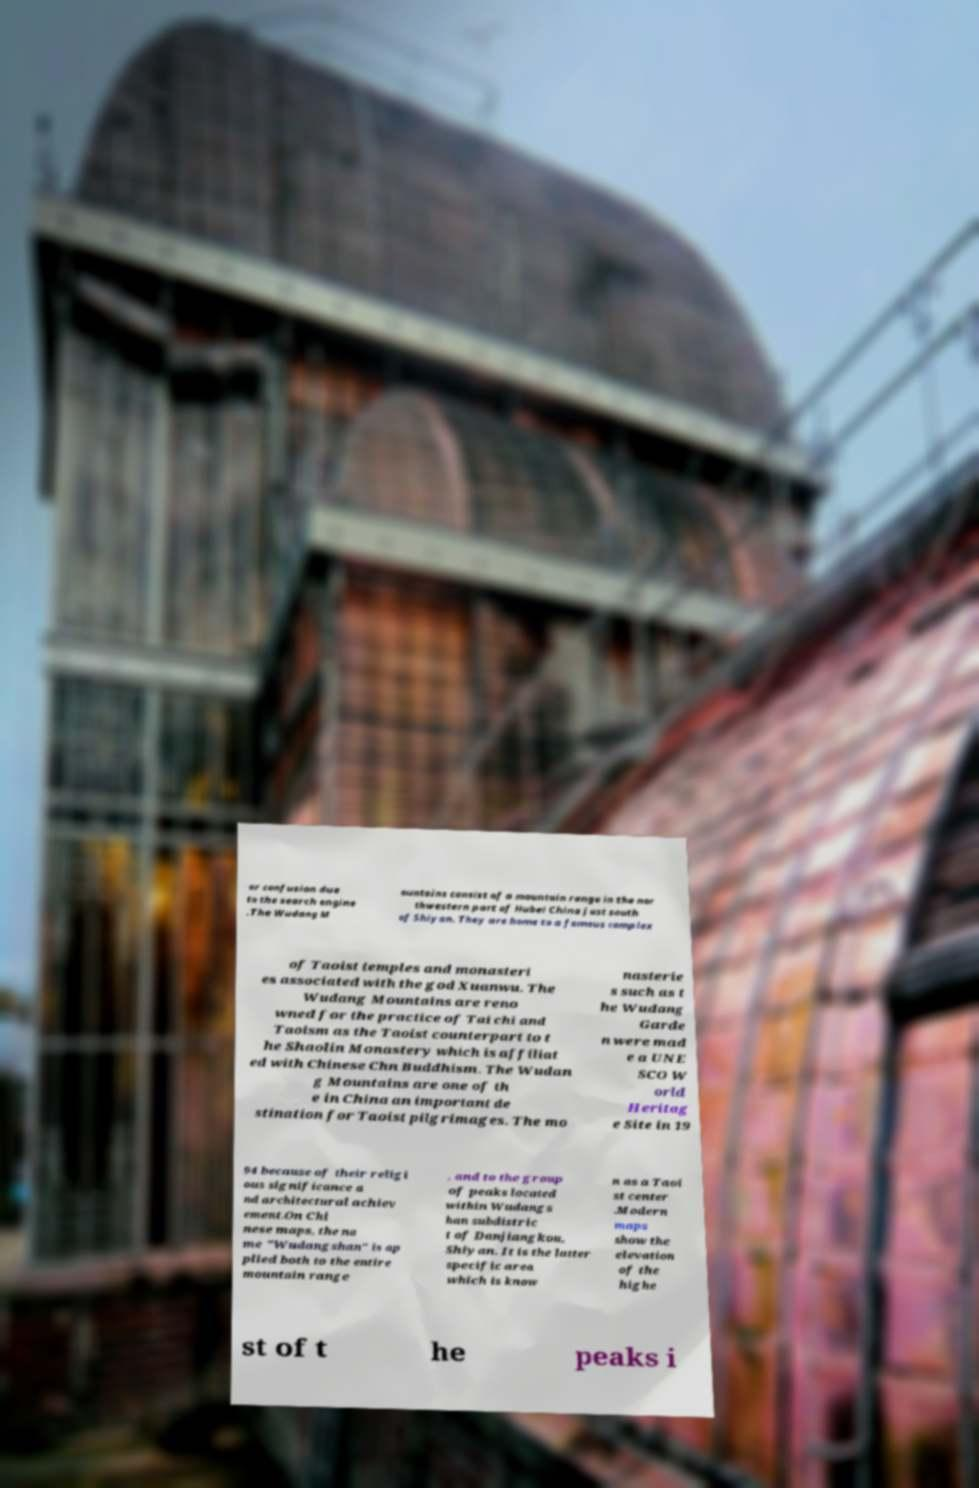Could you assist in decoding the text presented in this image and type it out clearly? or confusion due to the search engine .The Wudang M ountains consist of a mountain range in the nor thwestern part of Hubei China just south of Shiyan. They are home to a famous complex of Taoist temples and monasteri es associated with the god Xuanwu. The Wudang Mountains are reno wned for the practice of Tai chi and Taoism as the Taoist counterpart to t he Shaolin Monastery which is affiliat ed with Chinese Chn Buddhism. The Wudan g Mountains are one of th e in China an important de stination for Taoist pilgrimages. The mo nasterie s such as t he Wudang Garde n were mad e a UNE SCO W orld Heritag e Site in 19 94 because of their religi ous significance a nd architectural achiev ement.On Chi nese maps, the na me "Wudangshan" is ap plied both to the entire mountain range , and to the group of peaks located within Wudangs han subdistric t of Danjiangkou, Shiyan. It is the latter specific area which is know n as a Taoi st center .Modern maps show the elevation of the highe st of t he peaks i 